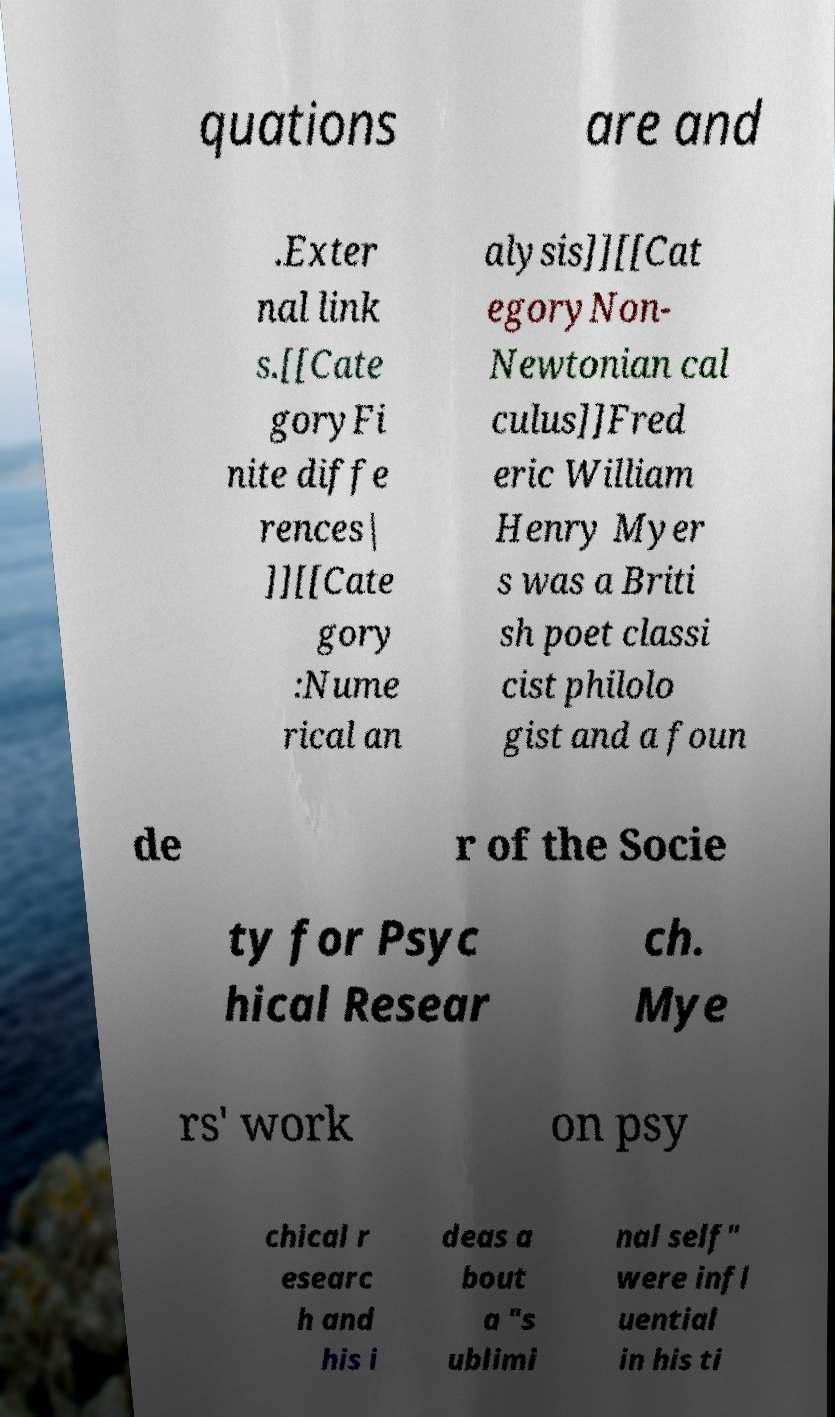Please read and relay the text visible in this image. What does it say? quations are and .Exter nal link s.[[Cate goryFi nite diffe rences| ]][[Cate gory :Nume rical an alysis]][[Cat egoryNon- Newtonian cal culus]]Fred eric William Henry Myer s was a Briti sh poet classi cist philolo gist and a foun de r of the Socie ty for Psyc hical Resear ch. Mye rs' work on psy chical r esearc h and his i deas a bout a "s ublimi nal self" were infl uential in his ti 